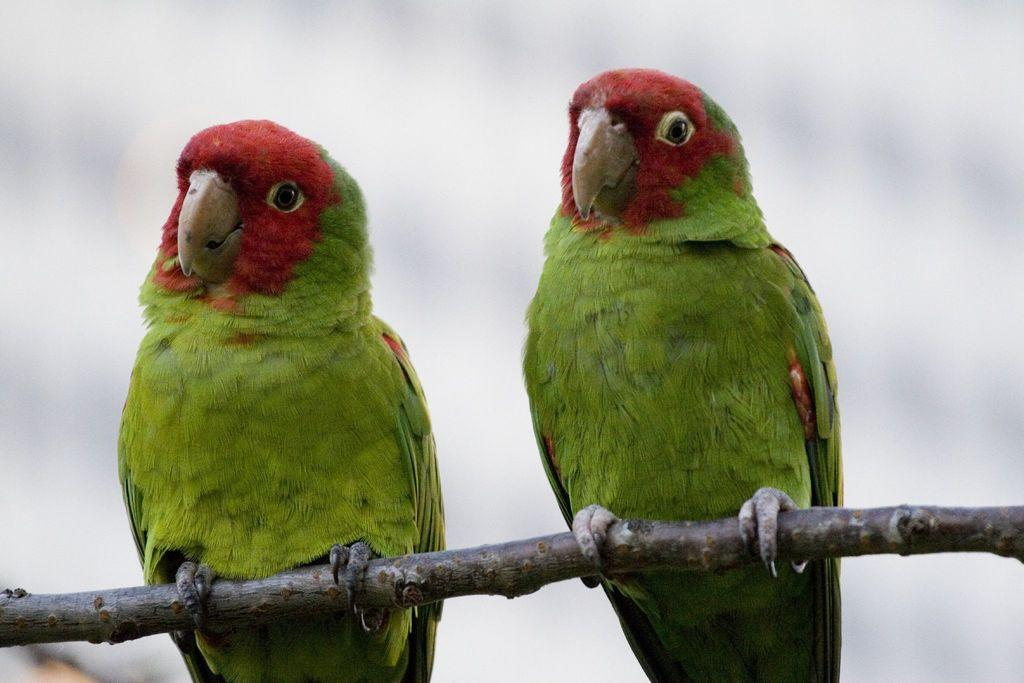How many parrots are in the image? There are two parrots in the image. Where are the parrots located in the image? The parrots are on a branch. What can be observed about the background of the image? The background of the image is blurred. What type of treatment do the sisters receive in the image? There are no sisters present in the image, and therefore no treatment can be observed. What action are the parrots performing in the image? The provided facts do not mention any specific actions performed by the parrots. 